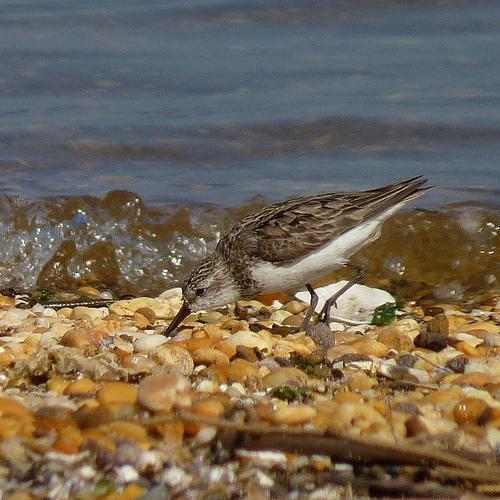How many birds are in this picture?
Give a very brief answer. 1. How many legs does the bird have?
Give a very brief answer. 2. 